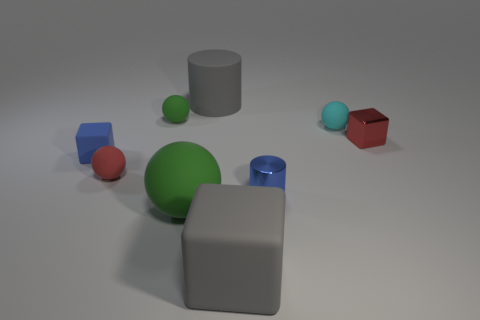Are there any other things that are the same shape as the tiny cyan rubber object?
Offer a very short reply. Yes. Is the size of the cylinder that is in front of the cyan matte ball the same as the matte cylinder?
Your answer should be very brief. No. There is a green rubber object behind the red rubber ball; what size is it?
Offer a very short reply. Small. Does the big green thing have the same shape as the blue metallic thing?
Provide a succinct answer. No. There is a red matte thing that is the same shape as the tiny cyan matte object; what is its size?
Offer a terse response. Small. There is a red object to the left of the large gray object that is behind the tiny red cube; what size is it?
Offer a terse response. Small. There is another small object that is the same shape as the red shiny thing; what is its color?
Keep it short and to the point. Blue. There is a small red object that is on the left side of the large matte cylinder; is its shape the same as the tiny cyan matte thing?
Offer a terse response. Yes. How many tiny red cubes are made of the same material as the small green sphere?
Your answer should be compact. 0. Is the color of the small rubber block the same as the shiny thing on the left side of the small cyan matte ball?
Offer a terse response. Yes. 